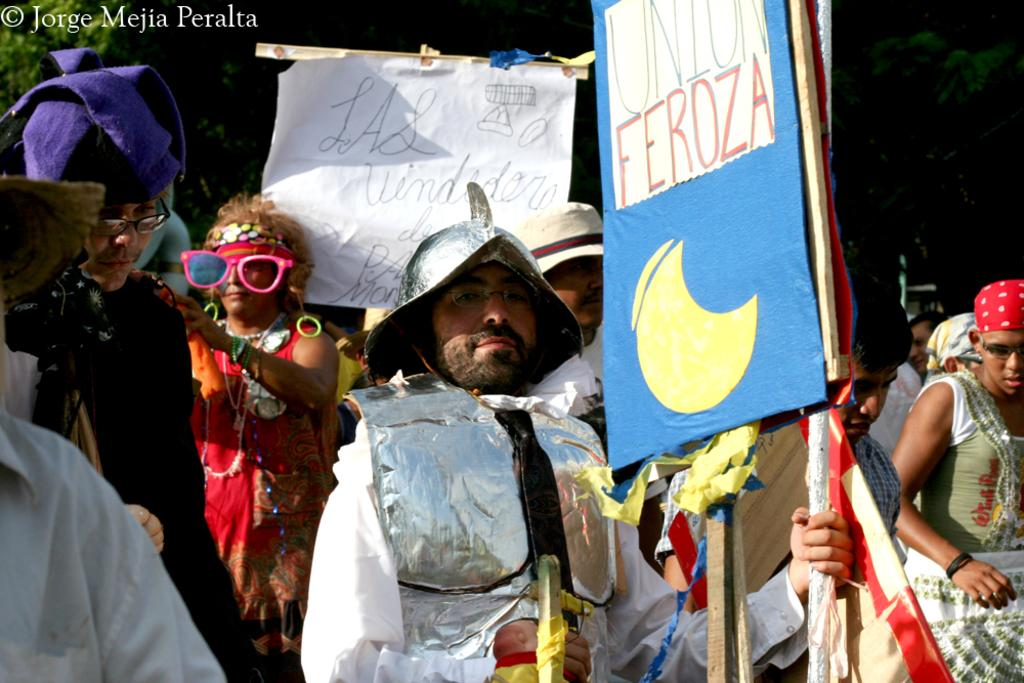Who or what can be seen in the image? There are people in the image. What are the people wearing? The people are wearing different costumes. What are the people holding in their hands? The people are holding placards. What can be seen in the distance behind the people? There are trees in the background of the image. Is there any dirt visible on the ground in the image? There is no information about the ground or dirt in the image, so it cannot be determined from the provided facts. 